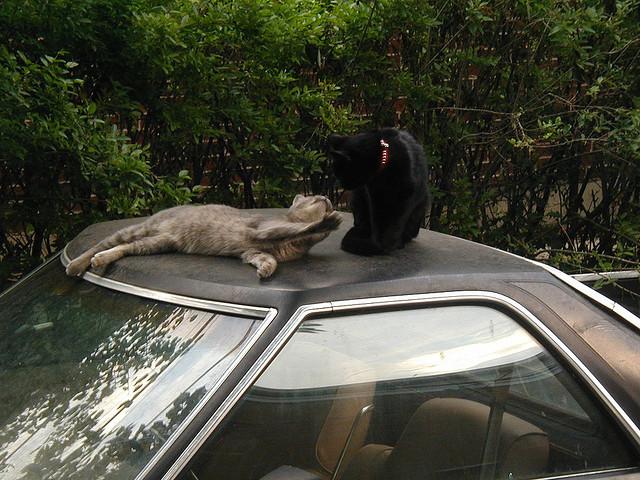Is this a modern car?
Give a very brief answer. No. What breed is this dog?
Quick response, please. No dog. Where is the cat?
Quick response, please. On car. How many cats?
Answer briefly. 2. Is the window open?
Quick response, please. No. What are they doing?
Give a very brief answer. Playing. What kind of animal is this?
Give a very brief answer. Cat. 